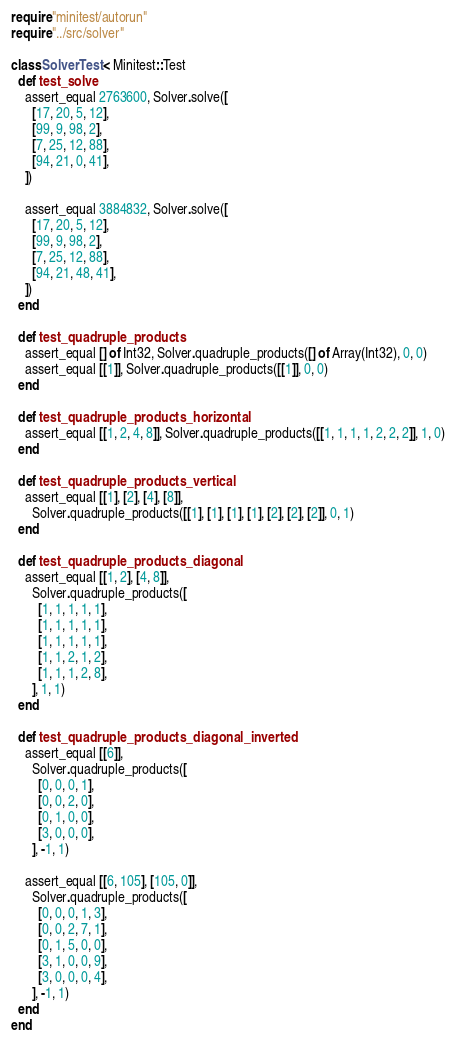<code> <loc_0><loc_0><loc_500><loc_500><_Crystal_>require "minitest/autorun"
require "../src/solver"

class SolverTest < Minitest::Test
  def test_solve
    assert_equal 2763600, Solver.solve([
      [17, 20, 5, 12],
      [99, 9, 98, 2],
      [7, 25, 12, 88],
      [94, 21, 0, 41],
    ])

    assert_equal 3884832, Solver.solve([
      [17, 20, 5, 12],
      [99, 9, 98, 2],
      [7, 25, 12, 88],
      [94, 21, 48, 41],
    ])
  end

  def test_quadruple_products
    assert_equal [] of Int32, Solver.quadruple_products([] of Array(Int32), 0, 0)
    assert_equal [[1]], Solver.quadruple_products([[1]], 0, 0)
  end

  def test_quadruple_products_horizontal
    assert_equal [[1, 2, 4, 8]], Solver.quadruple_products([[1, 1, 1, 1, 2, 2, 2]], 1, 0)
  end

  def test_quadruple_products_vertical
    assert_equal [[1], [2], [4], [8]],
      Solver.quadruple_products([[1], [1], [1], [1], [2], [2], [2]], 0, 1)
  end

  def test_quadruple_products_diagonal
    assert_equal [[1, 2], [4, 8]],
      Solver.quadruple_products([
        [1, 1, 1, 1, 1],
        [1, 1, 1, 1, 1],
        [1, 1, 1, 1, 1],
        [1, 1, 2, 1, 2],
        [1, 1, 1, 2, 8],
      ], 1, 1)
  end

  def test_quadruple_products_diagonal_inverted
    assert_equal [[6]],
      Solver.quadruple_products([
        [0, 0, 0, 1],
        [0, 0, 2, 0],
        [0, 1, 0, 0],
        [3, 0, 0, 0],
      ], -1, 1)

    assert_equal [[6, 105], [105, 0]],
      Solver.quadruple_products([
        [0, 0, 0, 1, 3],
        [0, 0, 2, 7, 1],
        [0, 1, 5, 0, 0],
        [3, 1, 0, 0, 9],
        [3, 0, 0, 0, 4],
      ], -1, 1)
  end
end
</code> 